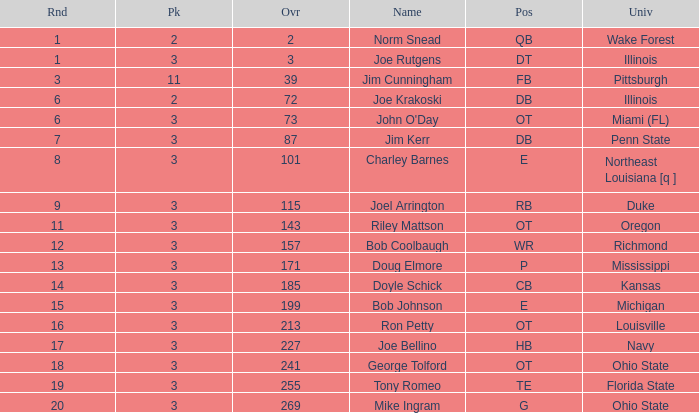How many rounds have john o'day as the name, and a pick less than 3? None. 